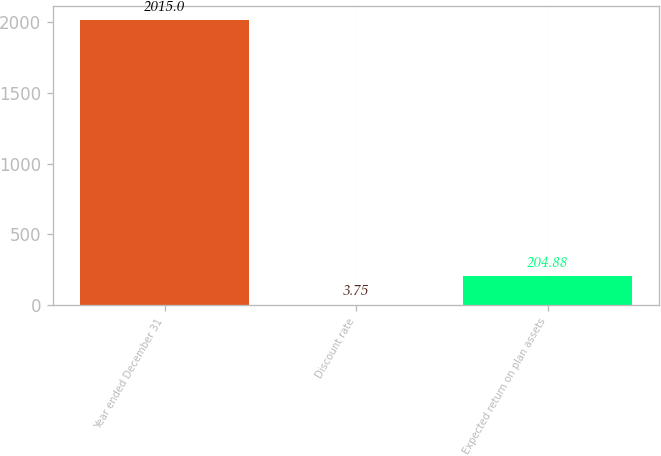<chart> <loc_0><loc_0><loc_500><loc_500><bar_chart><fcel>Year ended December 31<fcel>Discount rate<fcel>Expected return on plan assets<nl><fcel>2015<fcel>3.75<fcel>204.88<nl></chart> 